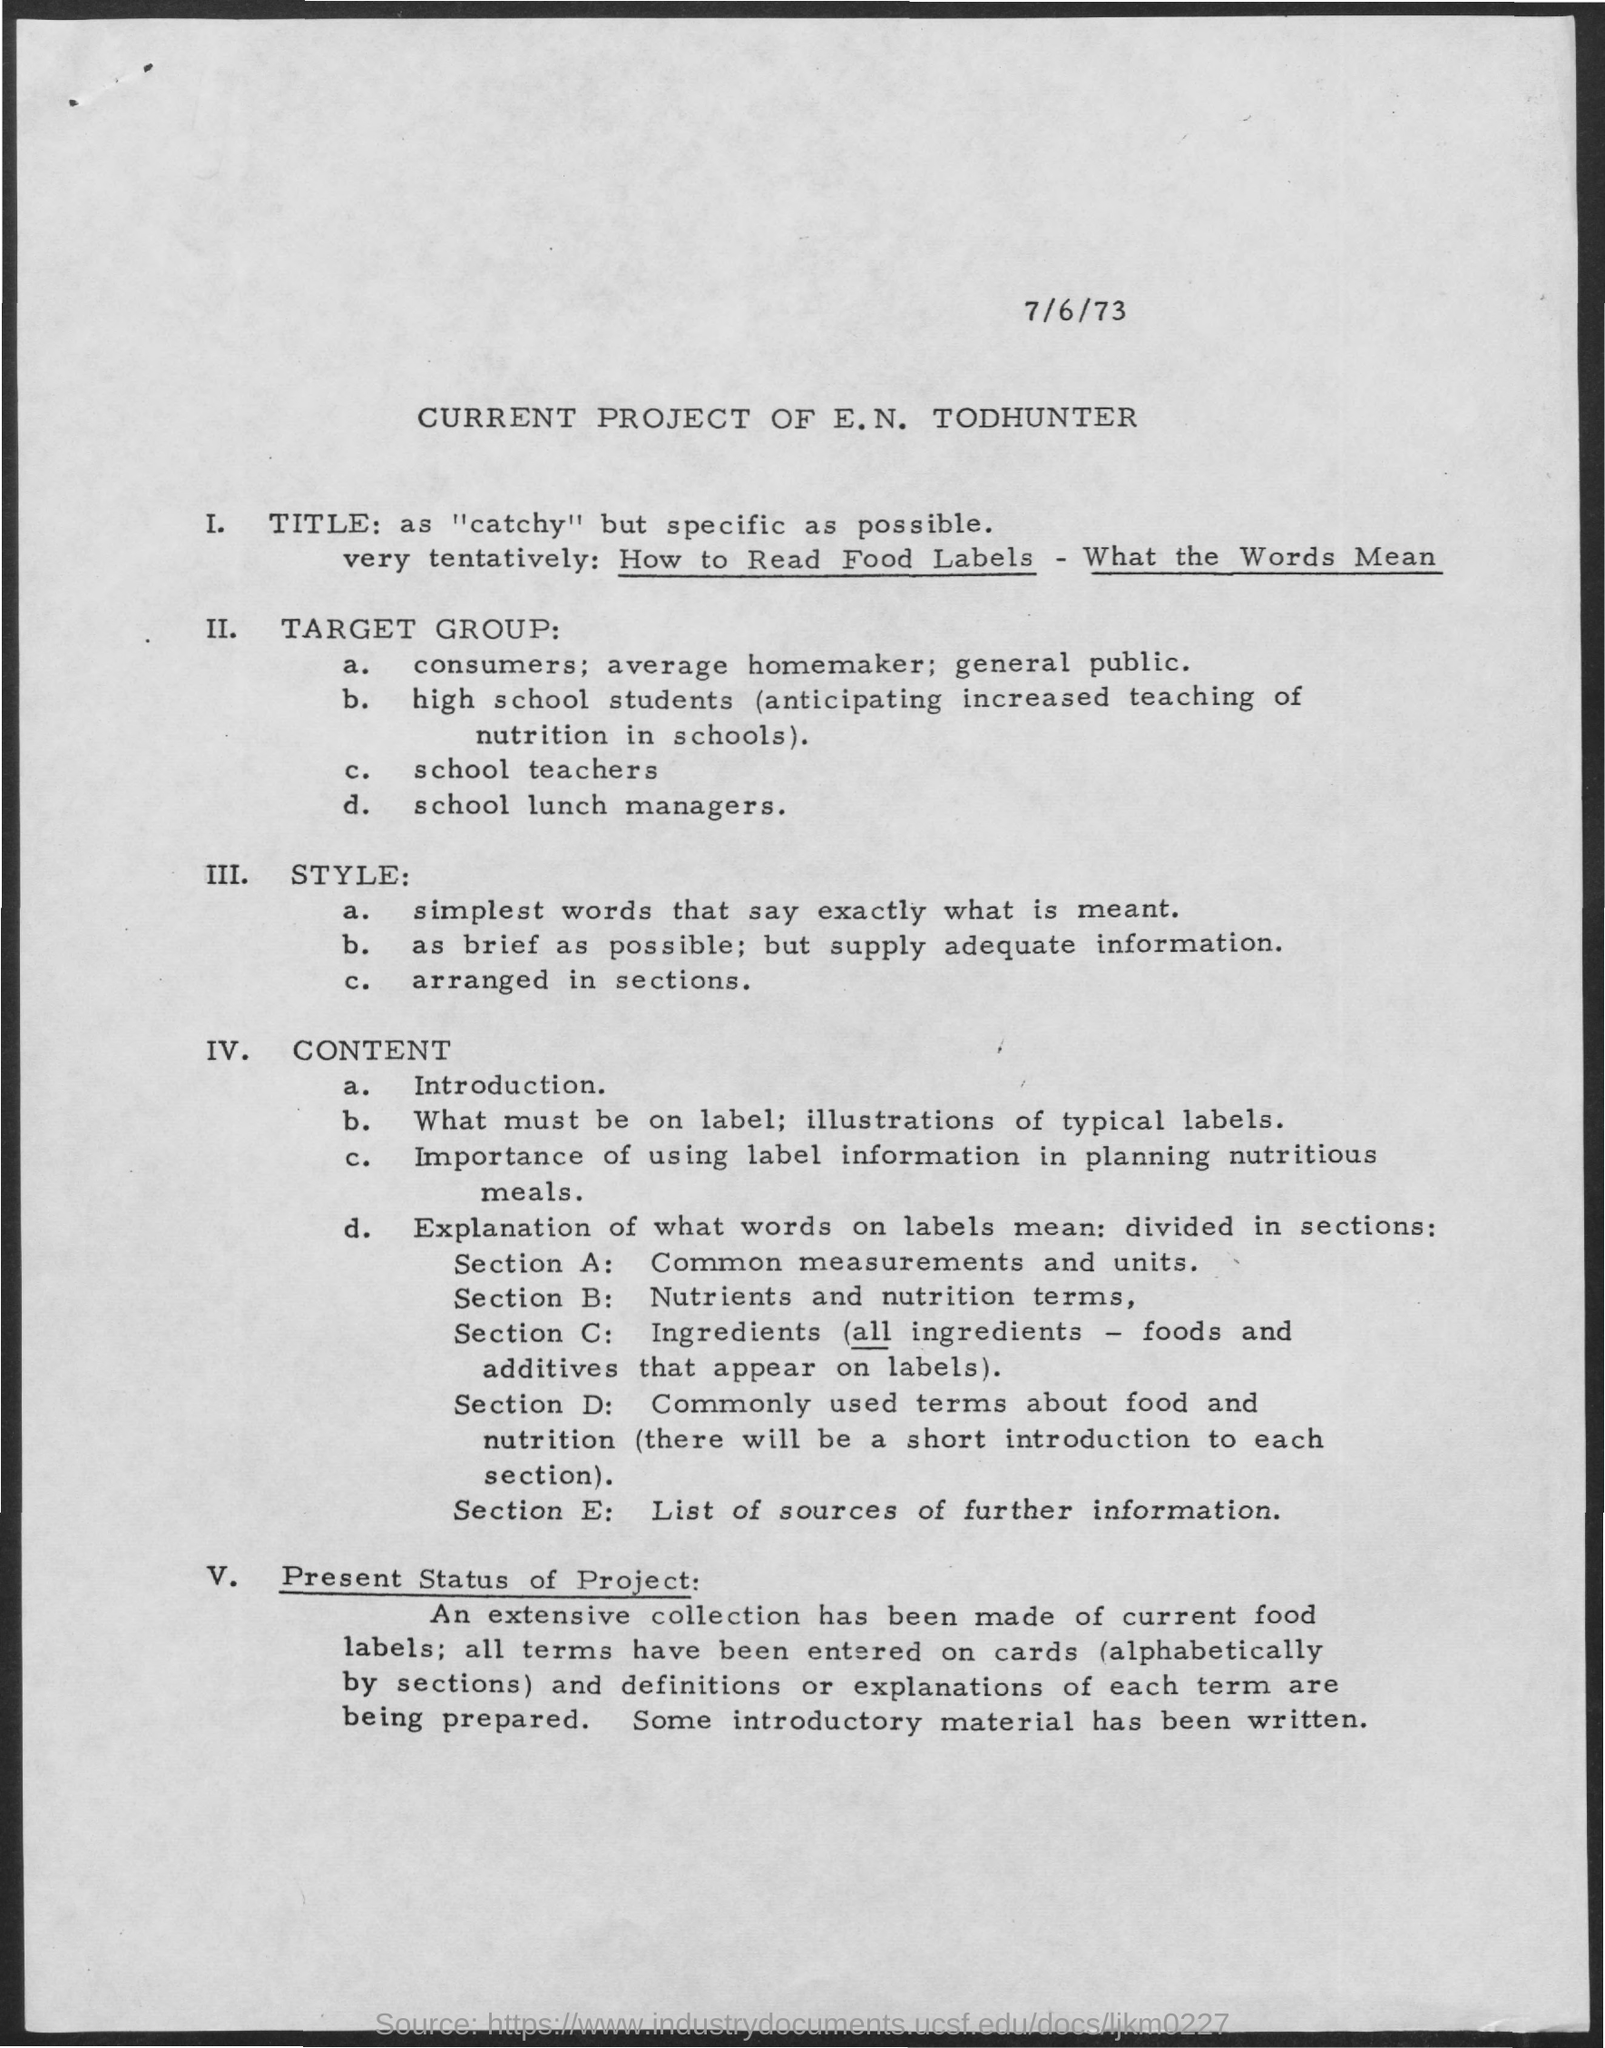What is the title mentioned in the given page ?
Give a very brief answer. As "catchy" but specific as possible. What  is mentioned in section a ?
Your answer should be very brief. Common measurements and units. What is mentioned in section d ?
Give a very brief answer. Commonly used terms about food and nutrition. What is mentioned in section b ?
Provide a short and direct response. NUTRIENTS AND NUTRITION TERMS. What is mentioned in section e?
Give a very brief answer. List of sources of further information. What is the date mentioned in the given page ?
Your answer should be compact. 7/6/73. 